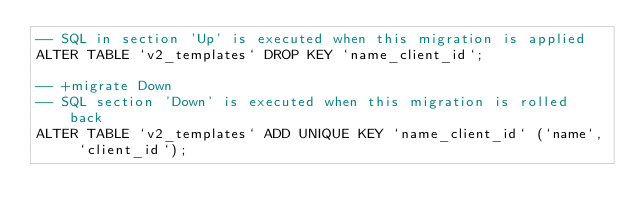<code> <loc_0><loc_0><loc_500><loc_500><_SQL_>-- SQL in section 'Up' is executed when this migration is applied
ALTER TABLE `v2_templates` DROP KEY `name_client_id`;

-- +migrate Down
-- SQL section 'Down' is executed when this migration is rolled back
ALTER TABLE `v2_templates` ADD UNIQUE KEY `name_client_id` (`name`, `client_id`);
</code> 